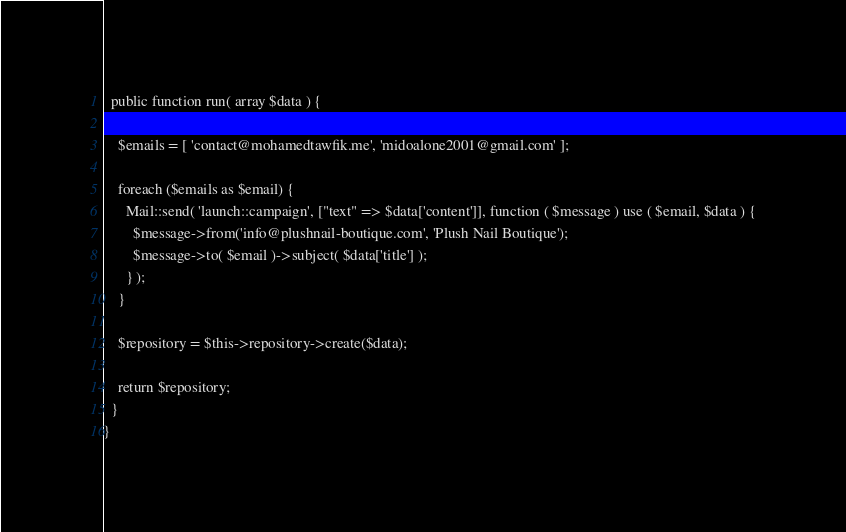<code> <loc_0><loc_0><loc_500><loc_500><_PHP_>  public function run( array $data ) {

    $emails = [ 'contact@mohamedtawfik.me', 'midoalone2001@gmail.com' ];

    foreach ($emails as $email) {
      Mail::send( 'launch::campaign', ["text" => $data['content']], function ( $message ) use ( $email, $data ) {
        $message->from('info@plushnail-boutique.com', 'Plush Nail Boutique');
        $message->to( $email )->subject( $data['title'] );
      } );
    }

    $repository = $this->repository->create($data);

    return $repository;
  }
}

</code> 